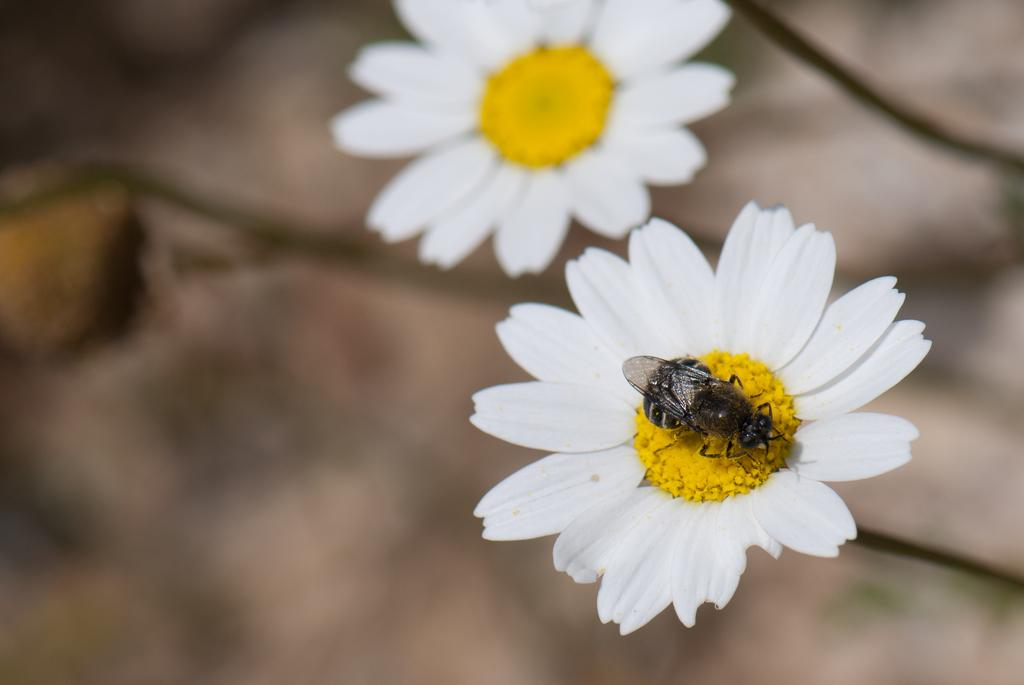What type of living organisms can be seen in the image? There are flowers and an insect in the image. Can you describe the insect's location in the image? The insect is on one of the flowers in the image. What can be observed about the background of the image? The background of the image is blurry. What type of pig can be seen starting its development in the image? There is no pig present in the image, and the concept of starting development is not applicable to the subjects in the image. 